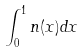<formula> <loc_0><loc_0><loc_500><loc_500>\int _ { 0 } ^ { 1 } n ( x ) d x</formula> 